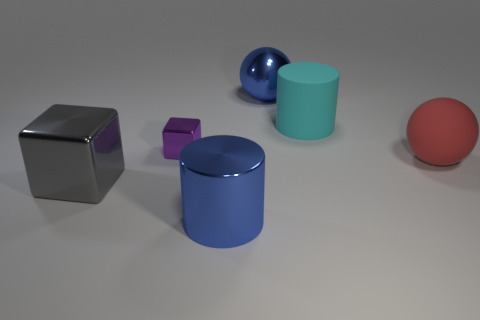Add 3 big metallic blocks. How many objects exist? 9 Subtract all cubes. How many objects are left? 4 Add 1 big shiny spheres. How many big shiny spheres are left? 2 Add 3 gray matte cylinders. How many gray matte cylinders exist? 3 Subtract 0 purple cylinders. How many objects are left? 6 Subtract all big cyan cylinders. Subtract all red metal cylinders. How many objects are left? 5 